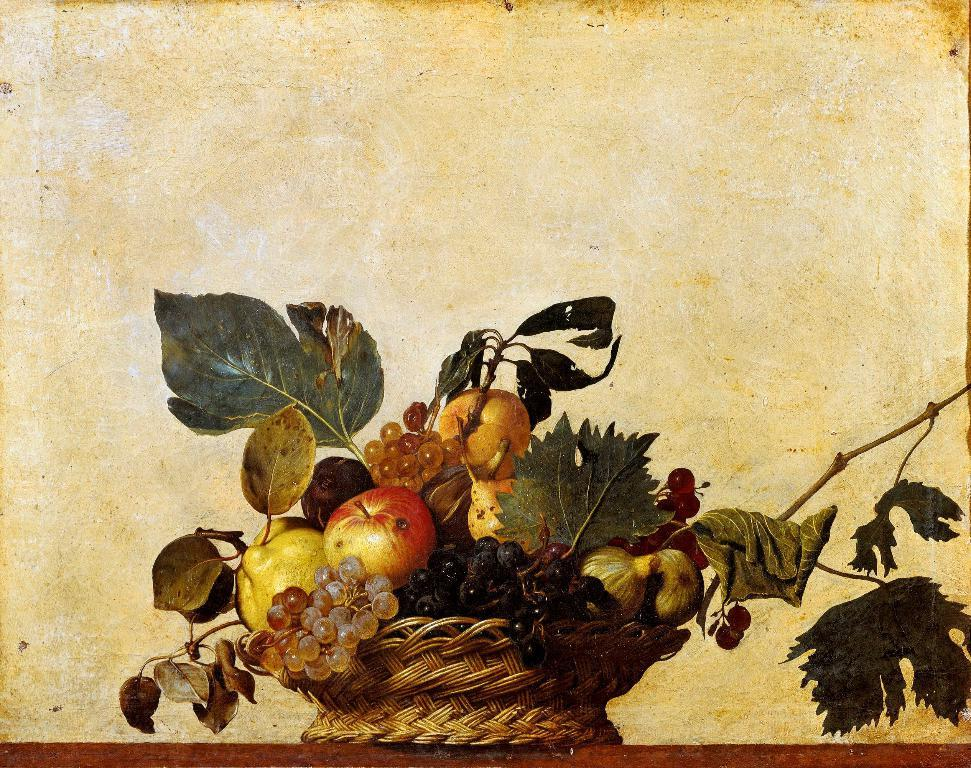What is the main subject of the image? There is a painting in the image. What objects are depicted in the painting? The painting contains a basket, fruits, and leaves. What type of business is being conducted in the painting? There is no indication of any business being conducted in the painting; it primarily features a basket, fruits, and leaves. 